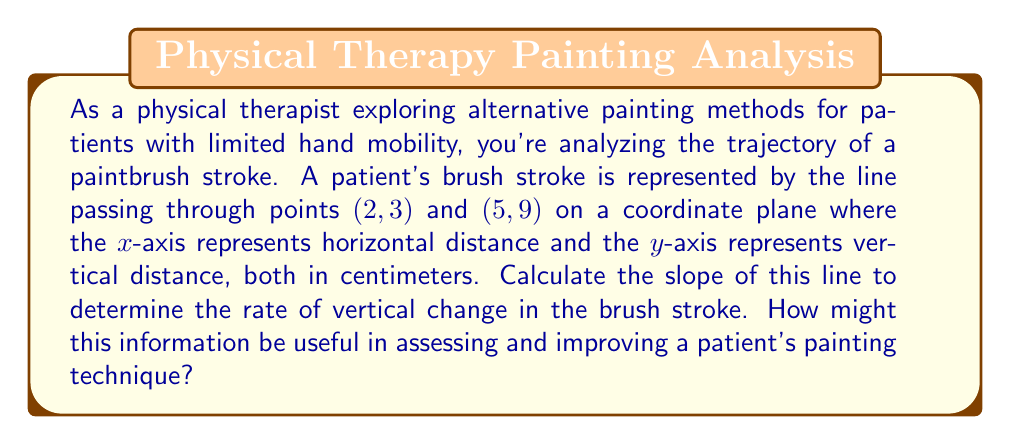Show me your answer to this math problem. To solve this problem, we'll use the slope formula:

$$m = \frac{y_2 - y_1}{x_2 - x_1}$$

Where $(x_1, y_1)$ and $(x_2, y_2)$ are two points on the line.

Given:
- Point 1: $(x_1, y_1) = (2, 3)$
- Point 2: $(x_2, y_2) = (5, 9)$

Let's substitute these values into the slope formula:

$$m = \frac{9 - 3}{5 - 2} = \frac{6}{3} = 2$$

The slope of the line is 2, which means for every 1 unit increase in x, y increases by 2 units.

In the context of a paintbrush stroke:
- The slope represents the rate of vertical change compared to horizontal change.
- A slope of 2 indicates a relatively steep upward stroke.
- This information can be useful for:
  1. Assessing the patient's current range of motion and control.
  2. Designing exercises to improve smooth, controlled movements.
  3. Adapting painting techniques to match the patient's capabilities.
  4. Tracking progress over time by comparing slopes of strokes.

[asy]
import graph;
size(200);
real f(real x) {return 2x-1;}
xaxis("x (cm)", arrow=Arrow);
yaxis("y (cm)", arrow=Arrow);
draw(graph(f,0,6));
dot((2,3));
dot((5,9));
label("(2,3)", (2,3), SW);
label("(5,9)", (5,9), NE);
[/asy]
Answer: The slope of the line representing the paintbrush stroke is 2. 